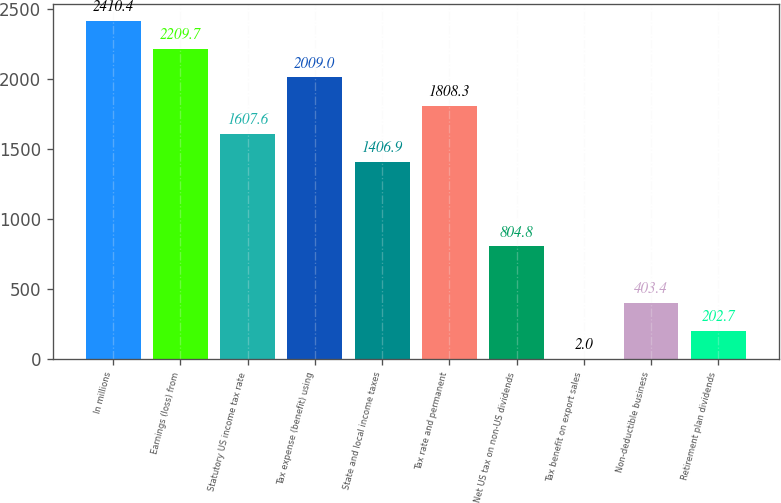<chart> <loc_0><loc_0><loc_500><loc_500><bar_chart><fcel>In millions<fcel>Earnings (loss) from<fcel>Statutory US income tax rate<fcel>Tax expense (benefit) using<fcel>State and local income taxes<fcel>Tax rate and permanent<fcel>Net US tax on non-US dividends<fcel>Tax benefit on export sales<fcel>Non-deductible business<fcel>Retirement plan dividends<nl><fcel>2410.4<fcel>2209.7<fcel>1607.6<fcel>2009<fcel>1406.9<fcel>1808.3<fcel>804.8<fcel>2<fcel>403.4<fcel>202.7<nl></chart> 